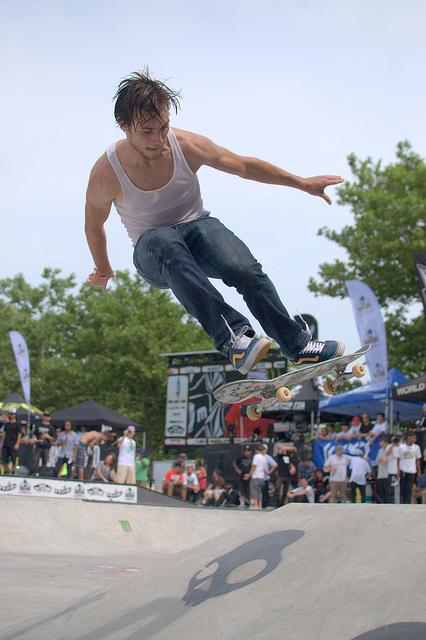What is this guy doing?
Short answer required. Skateboarding. What kind of competition is pictured?
Give a very brief answer. Skateboarding. What is the name of this skate park?
Be succinct. Skate. What is the man riding in the air?
Keep it brief. Skateboard. 